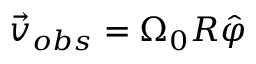<formula> <loc_0><loc_0><loc_500><loc_500>\vec { v } _ { o b s } = \Omega _ { 0 } R \hat { \varphi }</formula> 